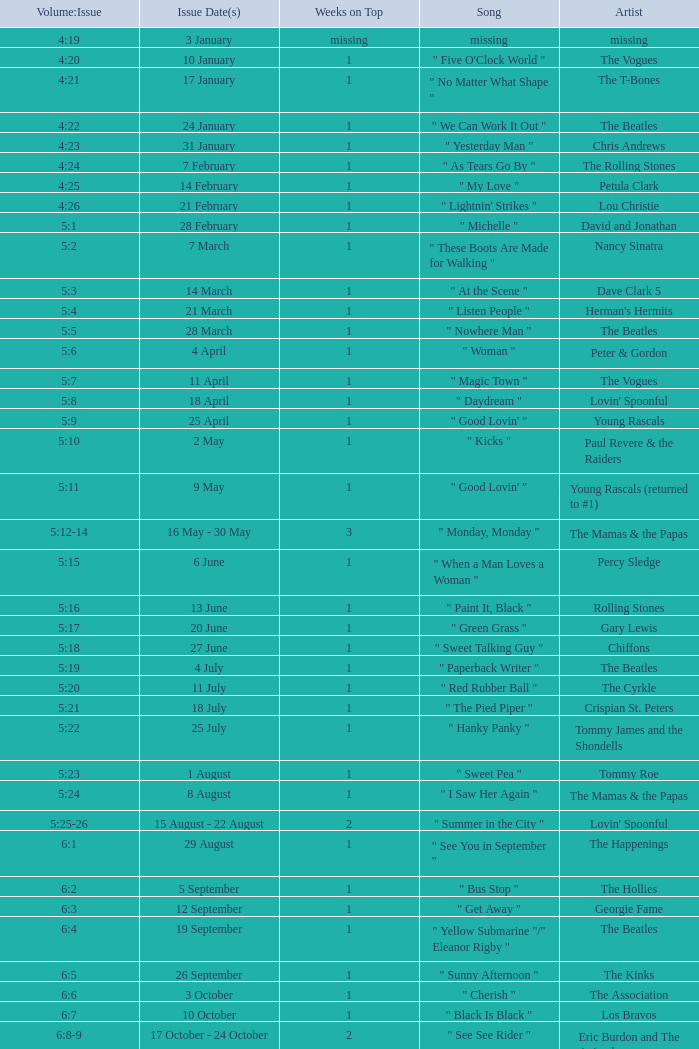An artist of the Beatles with an issue date(s) of 19 September has what as the listed weeks on top? 1.0. 